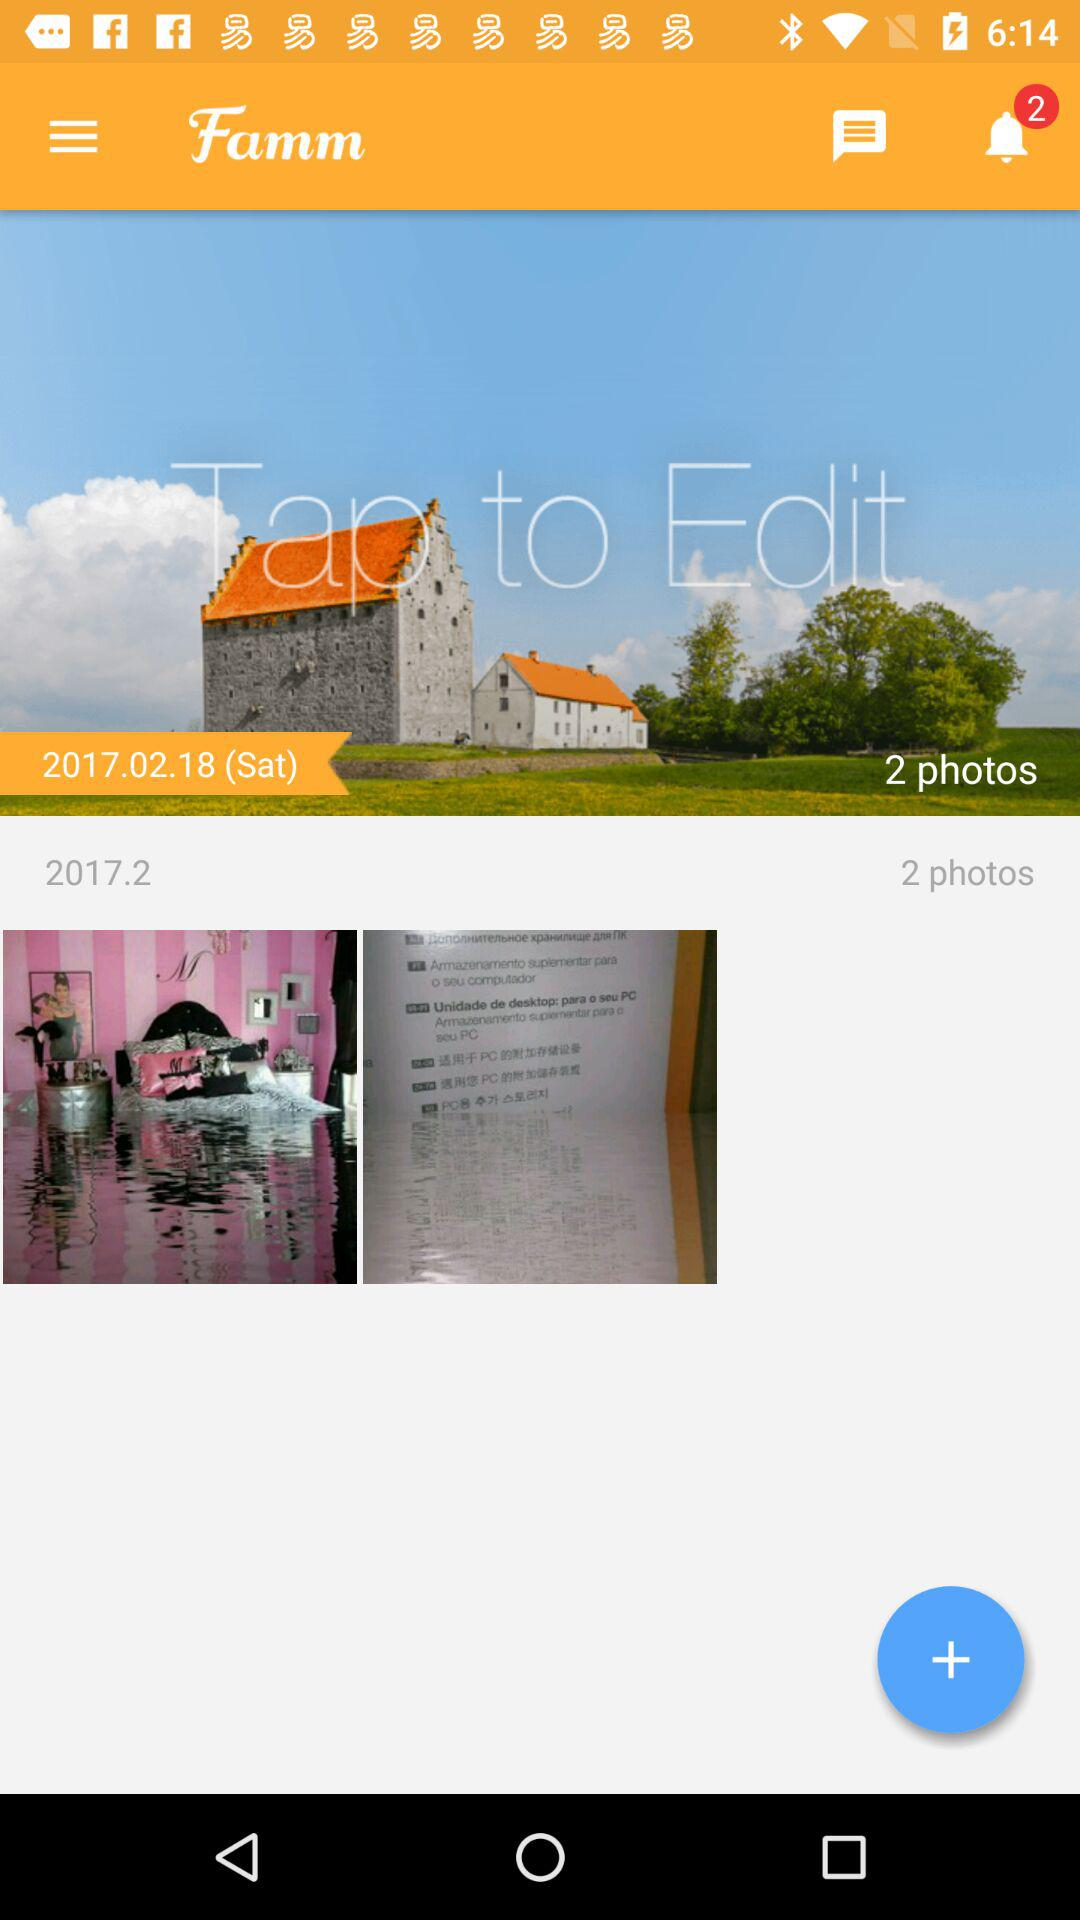Which day is on February 18, 2017? The day is Saturday. 